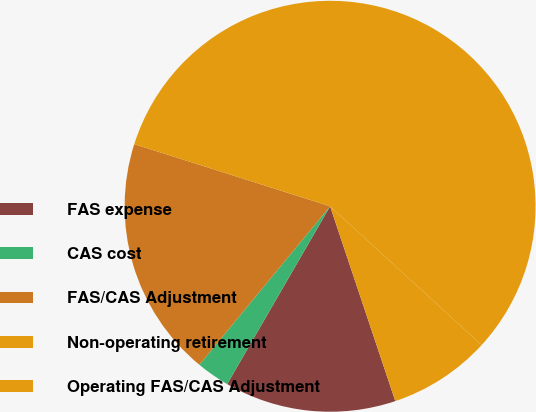Convert chart. <chart><loc_0><loc_0><loc_500><loc_500><pie_chart><fcel>FAS expense<fcel>CAS cost<fcel>FAS/CAS Adjustment<fcel>Non-operating retirement<fcel>Operating FAS/CAS Adjustment<nl><fcel>13.49%<fcel>2.63%<fcel>18.91%<fcel>56.91%<fcel>8.06%<nl></chart> 